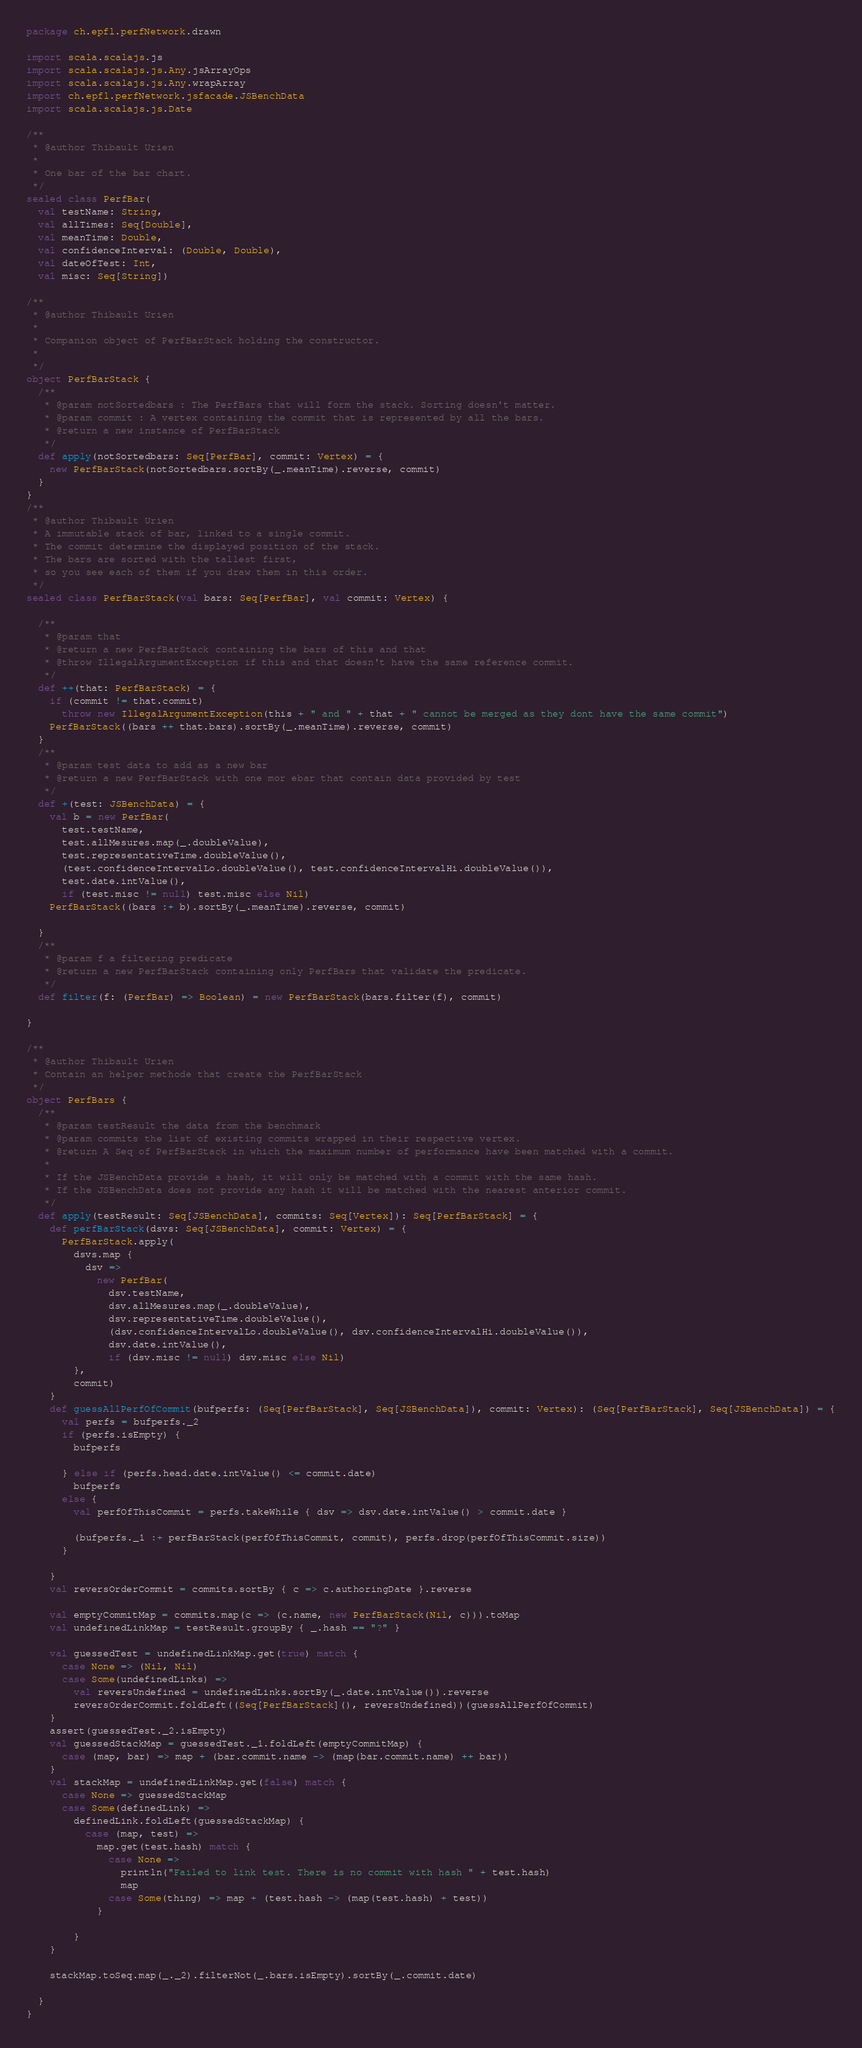Convert code to text. <code><loc_0><loc_0><loc_500><loc_500><_Scala_>package ch.epfl.perfNetwork.drawn

import scala.scalajs.js
import scala.scalajs.js.Any.jsArrayOps
import scala.scalajs.js.Any.wrapArray
import ch.epfl.perfNetwork.jsfacade.JSBenchData
import scala.scalajs.js.Date

/**
 * @author Thibault Urien
 *
 * One bar of the bar chart.
 */
sealed class PerfBar(
  val testName: String,
  val allTimes: Seq[Double],
  val meanTime: Double,
  val confidenceInterval: (Double, Double),
  val dateOfTest: Int,
  val misc: Seq[String])

/**
 * @author Thibault Urien
 *
 * Companion object of PerfBarStack holding the constructor.
 *
 */
object PerfBarStack {
  /**
   * @param notSortedbars : The PerfBars that will form the stack. Sorting doesn't matter.
   * @param commit : A vertex containing the commit that is represented by all the bars.
   * @return a new instance of PerfBarStack
   */
  def apply(notSortedbars: Seq[PerfBar], commit: Vertex) = {
    new PerfBarStack(notSortedbars.sortBy(_.meanTime).reverse, commit)
  }
}
/**
 * @author Thibault Urien
 * A immutable stack of bar, linked to a single commit.
 * The commit determine the displayed position of the stack.
 * The bars are sorted with the tallest first,
 * so you see each of them if you draw them in this order.
 */
sealed class PerfBarStack(val bars: Seq[PerfBar], val commit: Vertex) {

  /**
   * @param that
   * @return a new PerfBarStack containing the bars of this and that
   * @throw IllegalArgumentException if this and that doesn't have the same reference commit.
   */
  def ++(that: PerfBarStack) = {
    if (commit != that.commit)
      throw new IllegalArgumentException(this + " and " + that + " cannot be merged as they dont have the same commit")
    PerfBarStack((bars ++ that.bars).sortBy(_.meanTime).reverse, commit)
  }
  /**
   * @param test data to add as a new bar
   * @return a new PerfBarStack with one mor ebar that contain data provided by test
   */
  def +(test: JSBenchData) = {
    val b = new PerfBar(
      test.testName,
      test.allMesures.map(_.doubleValue),
      test.representativeTime.doubleValue(),
      (test.confidenceIntervalLo.doubleValue(), test.confidenceIntervalHi.doubleValue()),
      test.date.intValue(),
      if (test.misc != null) test.misc else Nil)
    PerfBarStack((bars :+ b).sortBy(_.meanTime).reverse, commit)

  }
  /**
   * @param f a filtering predicate
   * @return a new PerfBarStack containing only PerfBars that validate the predicate.
   */
  def filter(f: (PerfBar) => Boolean) = new PerfBarStack(bars.filter(f), commit)

}

/**
 * @author Thibault Urien
 * Contain an helper methode that create the PerfBarStack
 */
object PerfBars {
  /**
   * @param testResult the data from the benchmark
   * @param commits the list of existing commits wrapped in their respective vertex.
   * @return A Seq of PerfBarStack in which the maximum number of performance have been matched with a commit.
   *
   * If the JSBenchData provide a hash, it will only be matched with a commit with the same hash.
   * If the JSBenchData does not provide any hash it will be matched with the nearest anterior commit.
   */
  def apply(testResult: Seq[JSBenchData], commits: Seq[Vertex]): Seq[PerfBarStack] = {
    def perfBarStack(dsvs: Seq[JSBenchData], commit: Vertex) = {
      PerfBarStack.apply(
        dsvs.map {
          dsv =>
            new PerfBar(
              dsv.testName,
              dsv.allMesures.map(_.doubleValue),
              dsv.representativeTime.doubleValue(),
              (dsv.confidenceIntervalLo.doubleValue(), dsv.confidenceIntervalHi.doubleValue()),
              dsv.date.intValue(),
              if (dsv.misc != null) dsv.misc else Nil)
        },
        commit)
    }
    def guessAllPerfOfCommit(bufperfs: (Seq[PerfBarStack], Seq[JSBenchData]), commit: Vertex): (Seq[PerfBarStack], Seq[JSBenchData]) = {
      val perfs = bufperfs._2
      if (perfs.isEmpty) {
        bufperfs

      } else if (perfs.head.date.intValue() <= commit.date)
        bufperfs
      else {
        val perfOfThisCommit = perfs.takeWhile { dsv => dsv.date.intValue() > commit.date }

        (bufperfs._1 :+ perfBarStack(perfOfThisCommit, commit), perfs.drop(perfOfThisCommit.size))
      }

    }
    val reversOrderCommit = commits.sortBy { c => c.authoringDate }.reverse

    val emptyCommitMap = commits.map(c => (c.name, new PerfBarStack(Nil, c))).toMap
    val undefinedLinkMap = testResult.groupBy { _.hash == "?" }

    val guessedTest = undefinedLinkMap.get(true) match {
      case None => (Nil, Nil)
      case Some(undefinedLinks) =>
        val reversUndefined = undefinedLinks.sortBy(_.date.intValue()).reverse
        reversOrderCommit.foldLeft((Seq[PerfBarStack](), reversUndefined))(guessAllPerfOfCommit)
    }
    assert(guessedTest._2.isEmpty)
    val guessedStackMap = guessedTest._1.foldLeft(emptyCommitMap) {
      case (map, bar) => map + (bar.commit.name -> (map(bar.commit.name) ++ bar))
    }
    val stackMap = undefinedLinkMap.get(false) match {
      case None => guessedStackMap
      case Some(definedLink) =>
        definedLink.foldLeft(guessedStackMap) {
          case (map, test) =>
            map.get(test.hash) match {
              case None =>
                println("Failed to link test. There is no commit with hash " + test.hash)
                map
              case Some(thing) => map + (test.hash -> (map(test.hash) + test))
            }

        }
    }

    stackMap.toSeq.map(_._2).filterNot(_.bars.isEmpty).sortBy(_.commit.date)

  }
}</code> 